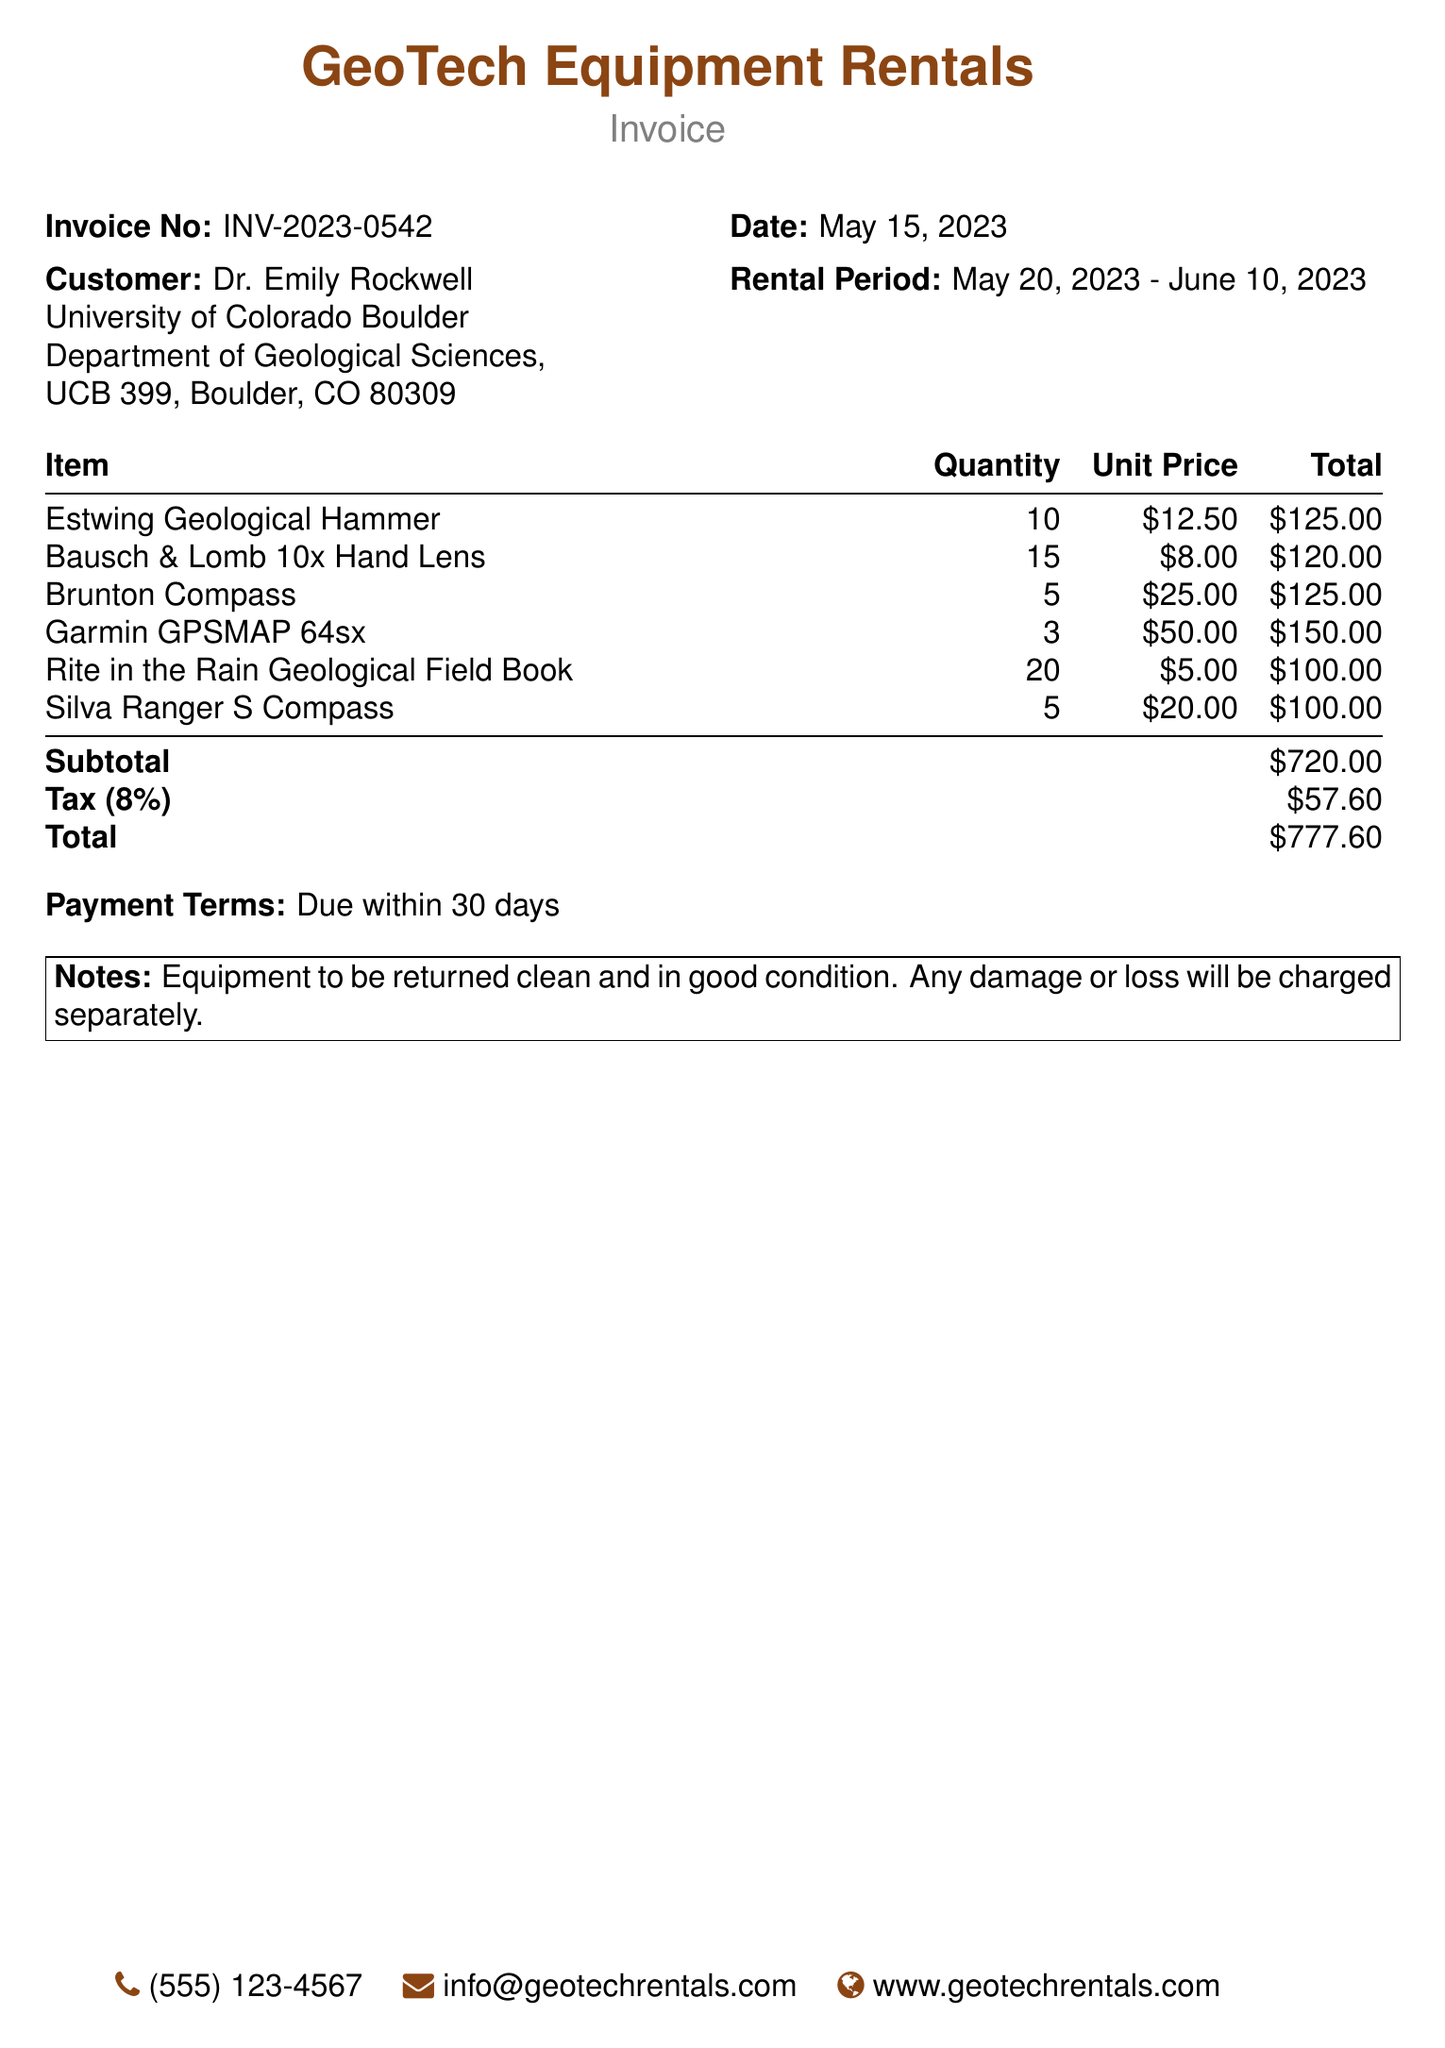What is the invoice number? The invoice number is listed at the top of the document, which is INV-2023-0542.
Answer: INV-2023-0542 Who is the customer? The customer's name and affiliation are provided in the document, which mentions Dr. Emily Rockwell.
Answer: Dr. Emily Rockwell What is the total amount due? The total amount is calculated at the bottom of the table and is mentioned as $777.60.
Answer: $777.60 What is the rental period? The rental period is noted in the document as May 20, 2023 - June 10, 2023.
Answer: May 20, 2023 - June 10, 2023 How many Estwing Geological Hammers were rented? The quantity for Estwing Geological Hammers is listed in the itemized section as 10.
Answer: 10 What is the tax rate applied in the invoice? The tax is indicated as 8% in the invoice details.
Answer: 8% What will happen if the equipment is returned damaged? The notes section states that any damage or loss will be charged separately.
Answer: Charged separately Which item has the highest unit price? The pricing information shows that the Garmin GPSMAP 64sx has the highest unit price at $50.00.
Answer: $50.00 What is the payment term specified in the document? The payment terms are clearly stated as due within 30 days.
Answer: Due within 30 days 